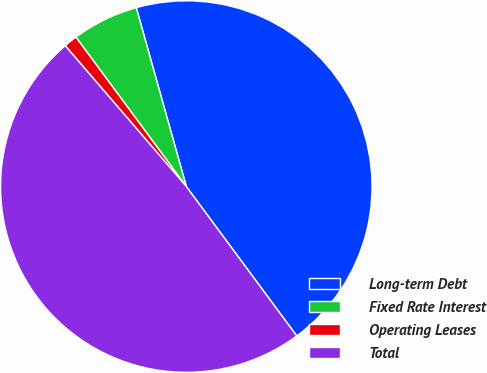<chart> <loc_0><loc_0><loc_500><loc_500><pie_chart><fcel>Long-term Debt<fcel>Fixed Rate Interest<fcel>Operating Leases<fcel>Total<nl><fcel>44.21%<fcel>5.79%<fcel>1.17%<fcel>48.83%<nl></chart> 